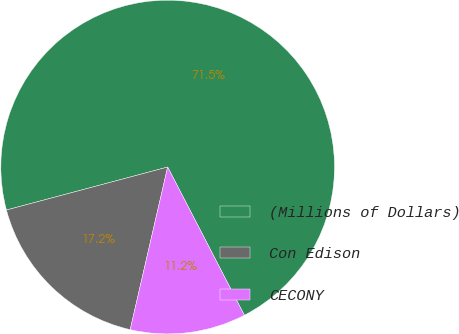<chart> <loc_0><loc_0><loc_500><loc_500><pie_chart><fcel>(Millions of Dollars)<fcel>Con Edison<fcel>CECONY<nl><fcel>71.54%<fcel>17.25%<fcel>11.21%<nl></chart> 